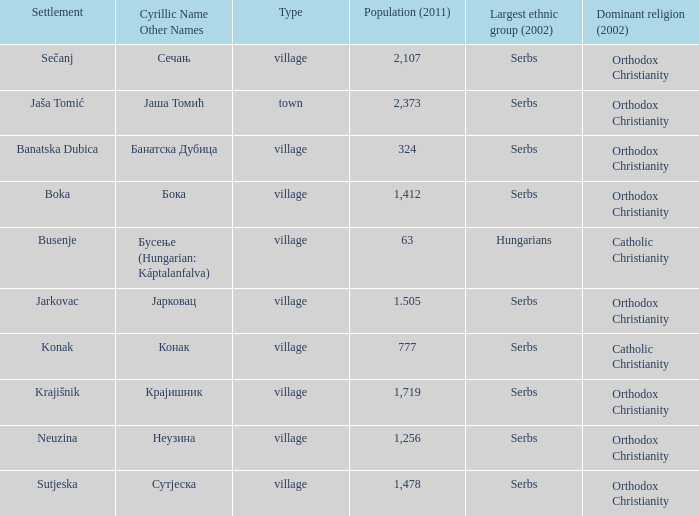Could you parse the entire table? {'header': ['Settlement', 'Cyrillic Name Other Names', 'Type', 'Population (2011)', 'Largest ethnic group (2002)', 'Dominant religion (2002)'], 'rows': [['Sečanj', 'Сечањ', 'village', '2,107', 'Serbs', 'Orthodox Christianity'], ['Jaša Tomić', 'Јаша Томић', 'town', '2,373', 'Serbs', 'Orthodox Christianity'], ['Banatska Dubica', 'Банатска Дубица', 'village', '324', 'Serbs', 'Orthodox Christianity'], ['Boka', 'Бока', 'village', '1,412', 'Serbs', 'Orthodox Christianity'], ['Busenje', 'Бусење (Hungarian: Káptalanfalva)', 'village', '63', 'Hungarians', 'Catholic Christianity'], ['Jarkovac', 'Јарковац', 'village', '1.505', 'Serbs', 'Orthodox Christianity'], ['Konak', 'Конак', 'village', '777', 'Serbs', 'Catholic Christianity'], ['Krajišnik', 'Крајишник', 'village', '1,719', 'Serbs', 'Orthodox Christianity'], ['Neuzina', 'Неузина', 'village', '1,256', 'Serbs', 'Orthodox Christianity'], ['Sutjeska', 'Сутјеска', 'village', '1,478', 'Serbs', 'Orthodox Christianity']]} The population is 2,107's dominant religion is? Orthodox Christianity. 